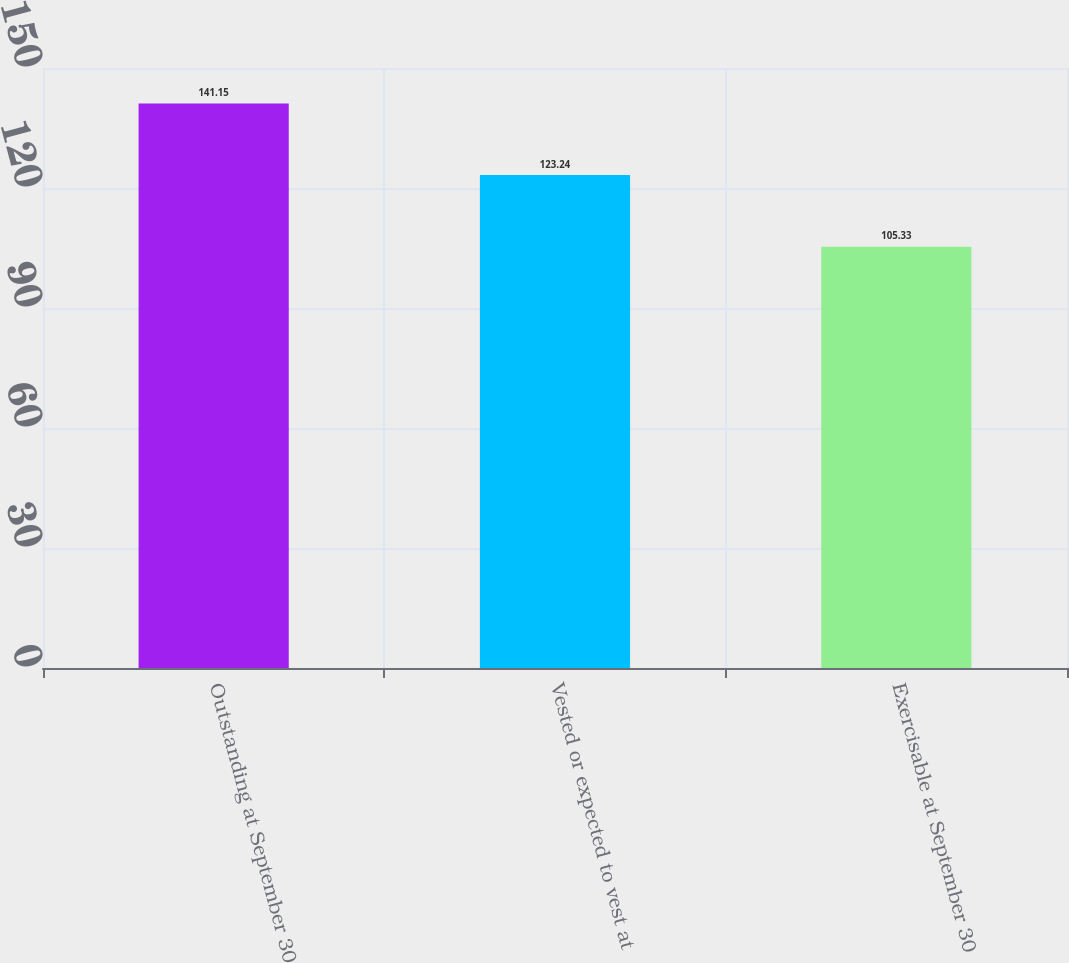<chart> <loc_0><loc_0><loc_500><loc_500><bar_chart><fcel>Outstanding at September 30<fcel>Vested or expected to vest at<fcel>Exercisable at September 30<nl><fcel>141.15<fcel>123.24<fcel>105.33<nl></chart> 